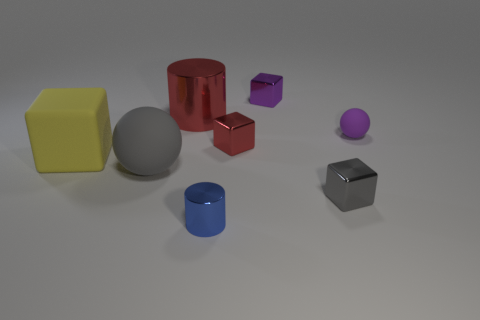Subtract 2 blocks. How many blocks are left? 2 Subtract all big yellow rubber cubes. How many cubes are left? 3 Subtract all red blocks. How many blocks are left? 3 Subtract all green cubes. Subtract all gray cylinders. How many cubes are left? 4 Add 1 large rubber spheres. How many objects exist? 9 Subtract all cylinders. How many objects are left? 6 Add 2 large cyan shiny balls. How many large cyan shiny balls exist? 2 Subtract 0 cyan cylinders. How many objects are left? 8 Subtract all gray things. Subtract all big red cylinders. How many objects are left? 5 Add 7 tiny matte balls. How many tiny matte balls are left? 8 